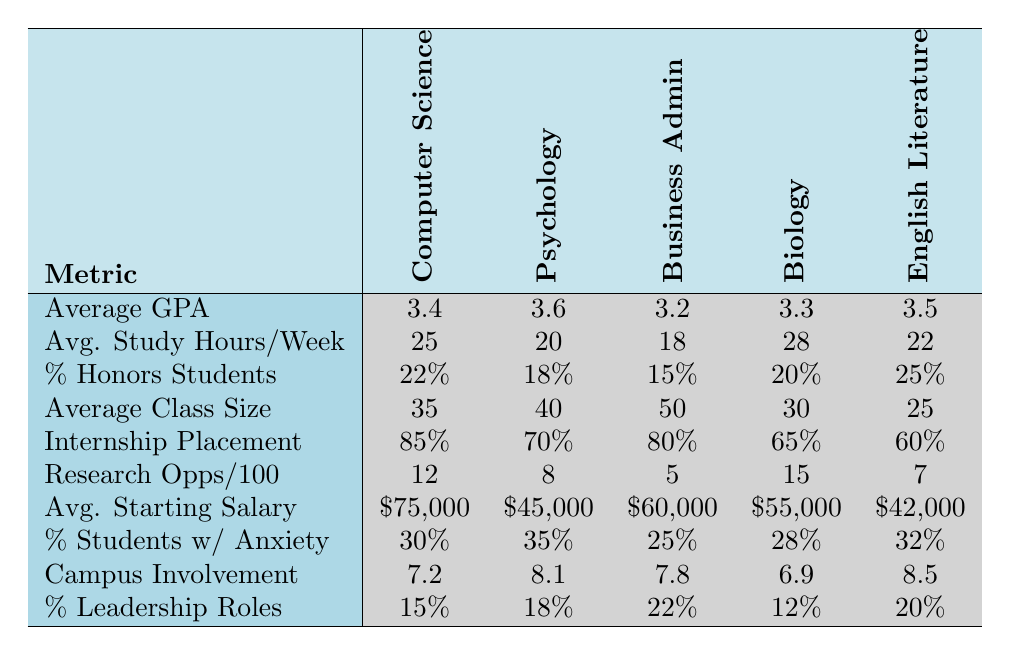What is the average GPA for Psychology majors? The table shows that the average GPA for Psychology is 3.6, which can be found directly in the corresponding row under the Psychology column.
Answer: 3.6 What is the average study hours per week for Business Administration majors? The average study hours per week for Business Administration is listed in the table as 18, located in the corresponding row for that major.
Answer: 18 Which major has the highest percentage of honors students? By reviewing the percentages in the "Percentage of Honors Students" row, English Literature has the highest at 25%.
Answer: English Literature What is the average starting salary for Computer Science graduates? The average starting salary for Computer Science is found in the corresponding row as $75,000.
Answer: $75,000 How many research opportunities are there per 100 students in Biology? The table indicates that there are 15 research opportunities per 100 students for Biology, found in the respective row.
Answer: 15 What is the average class size for English Literature? The average class size for English Literature is listed as 25 in the row corresponding to that major.
Answer: 25 Which major has the lowest internship placement rate? Looking at the "Internship Placement Rate" row, Biology has the lowest rate at 65%.
Answer: Biology Calculate the average GPA of all the majors listed. To find the average GPA, sum all the GPAs: 3.4 + 3.6 + 3.2 + 3.3 + 3.5 = 17.0. Then divide by the number of majors (5): 17.0 / 5 = 3.4.
Answer: 3.4 Is the percentage of students with anxiety higher in Psychology or Business Administration? The percentage of students with anxiety for Psychology is 35% while for Business Administration it is 25%. Since 35% is higher, the answer is Psychology has more.
Answer: Yes, Psychology If the average study hours per week in Biology increased by 5 hours, what would it be? The current average for Biology is 28. Adding 5 hours gives 28 + 5 = 33.
Answer: 33 What is the difference in average starting salaries between Computer Science and English Literature? The average starting salary for Computer Science is $75,000 and for English Literature is $42,000. The difference is $75,000 - $42,000 = $33,000.
Answer: $33,000 Which major has the highest campus involvement score? The campus involvement scores show that English Literature has the highest score at 8.5.
Answer: English Literature 